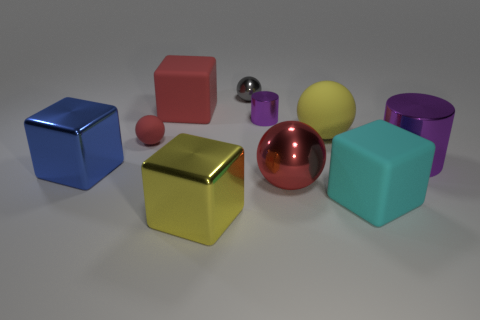How many other objects are there of the same color as the small rubber ball?
Offer a terse response. 2. The blue cube that is to the left of the red sphere that is behind the red sphere that is to the right of the large red matte object is made of what material?
Provide a short and direct response. Metal. The small metallic sphere is what color?
Keep it short and to the point. Gray. What number of small things are either cyan blocks or spheres?
Keep it short and to the point. 2. There is a block that is the same color as the tiny matte thing; what is its material?
Your answer should be compact. Rubber. Do the red object that is in front of the blue block and the large red object that is behind the big red ball have the same material?
Provide a short and direct response. No. Are there any big purple metal cubes?
Offer a very short reply. No. Is the number of large cyan objects left of the small cylinder greater than the number of large spheres that are behind the small gray sphere?
Provide a succinct answer. No. What is the material of the large yellow thing that is the same shape as the big blue metal thing?
Make the answer very short. Metal. Are there any other things that are the same size as the blue metallic block?
Make the answer very short. Yes. 